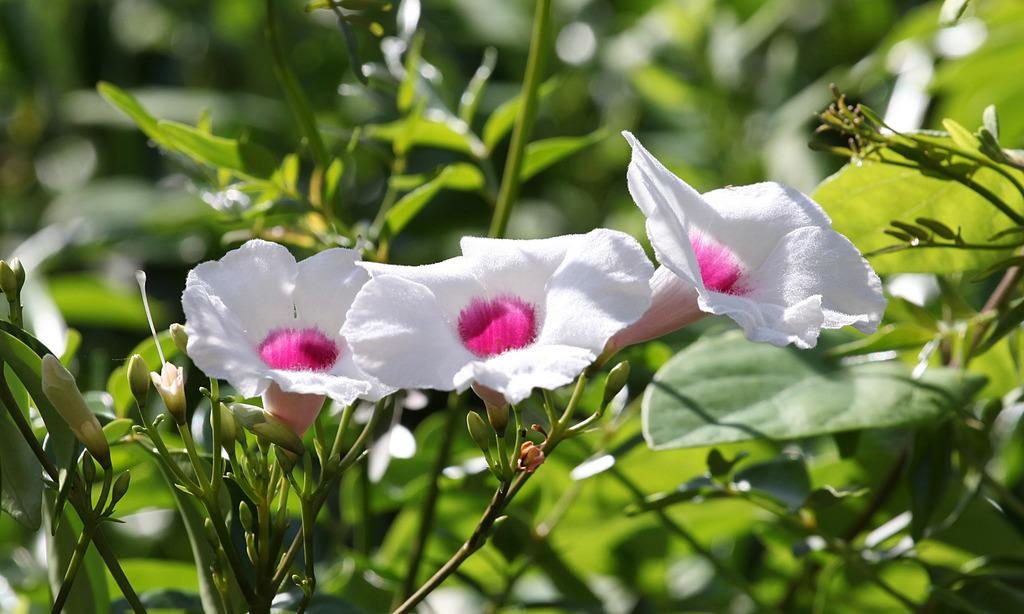What type of living organism can be seen in the picture? There is a plant in the picture. What specific feature of the plant is visible? There are flowers on the plant. What color are the flowers? The flowers are white in color. Is there any variation in the color of the flowers? Yes, the flowers have pink color in the middle. How does the plant attract the attention of its friend in the image? There is no indication in the image that the plant is attracting the attention of a friend, as the image only shows the plant and its flowers. 